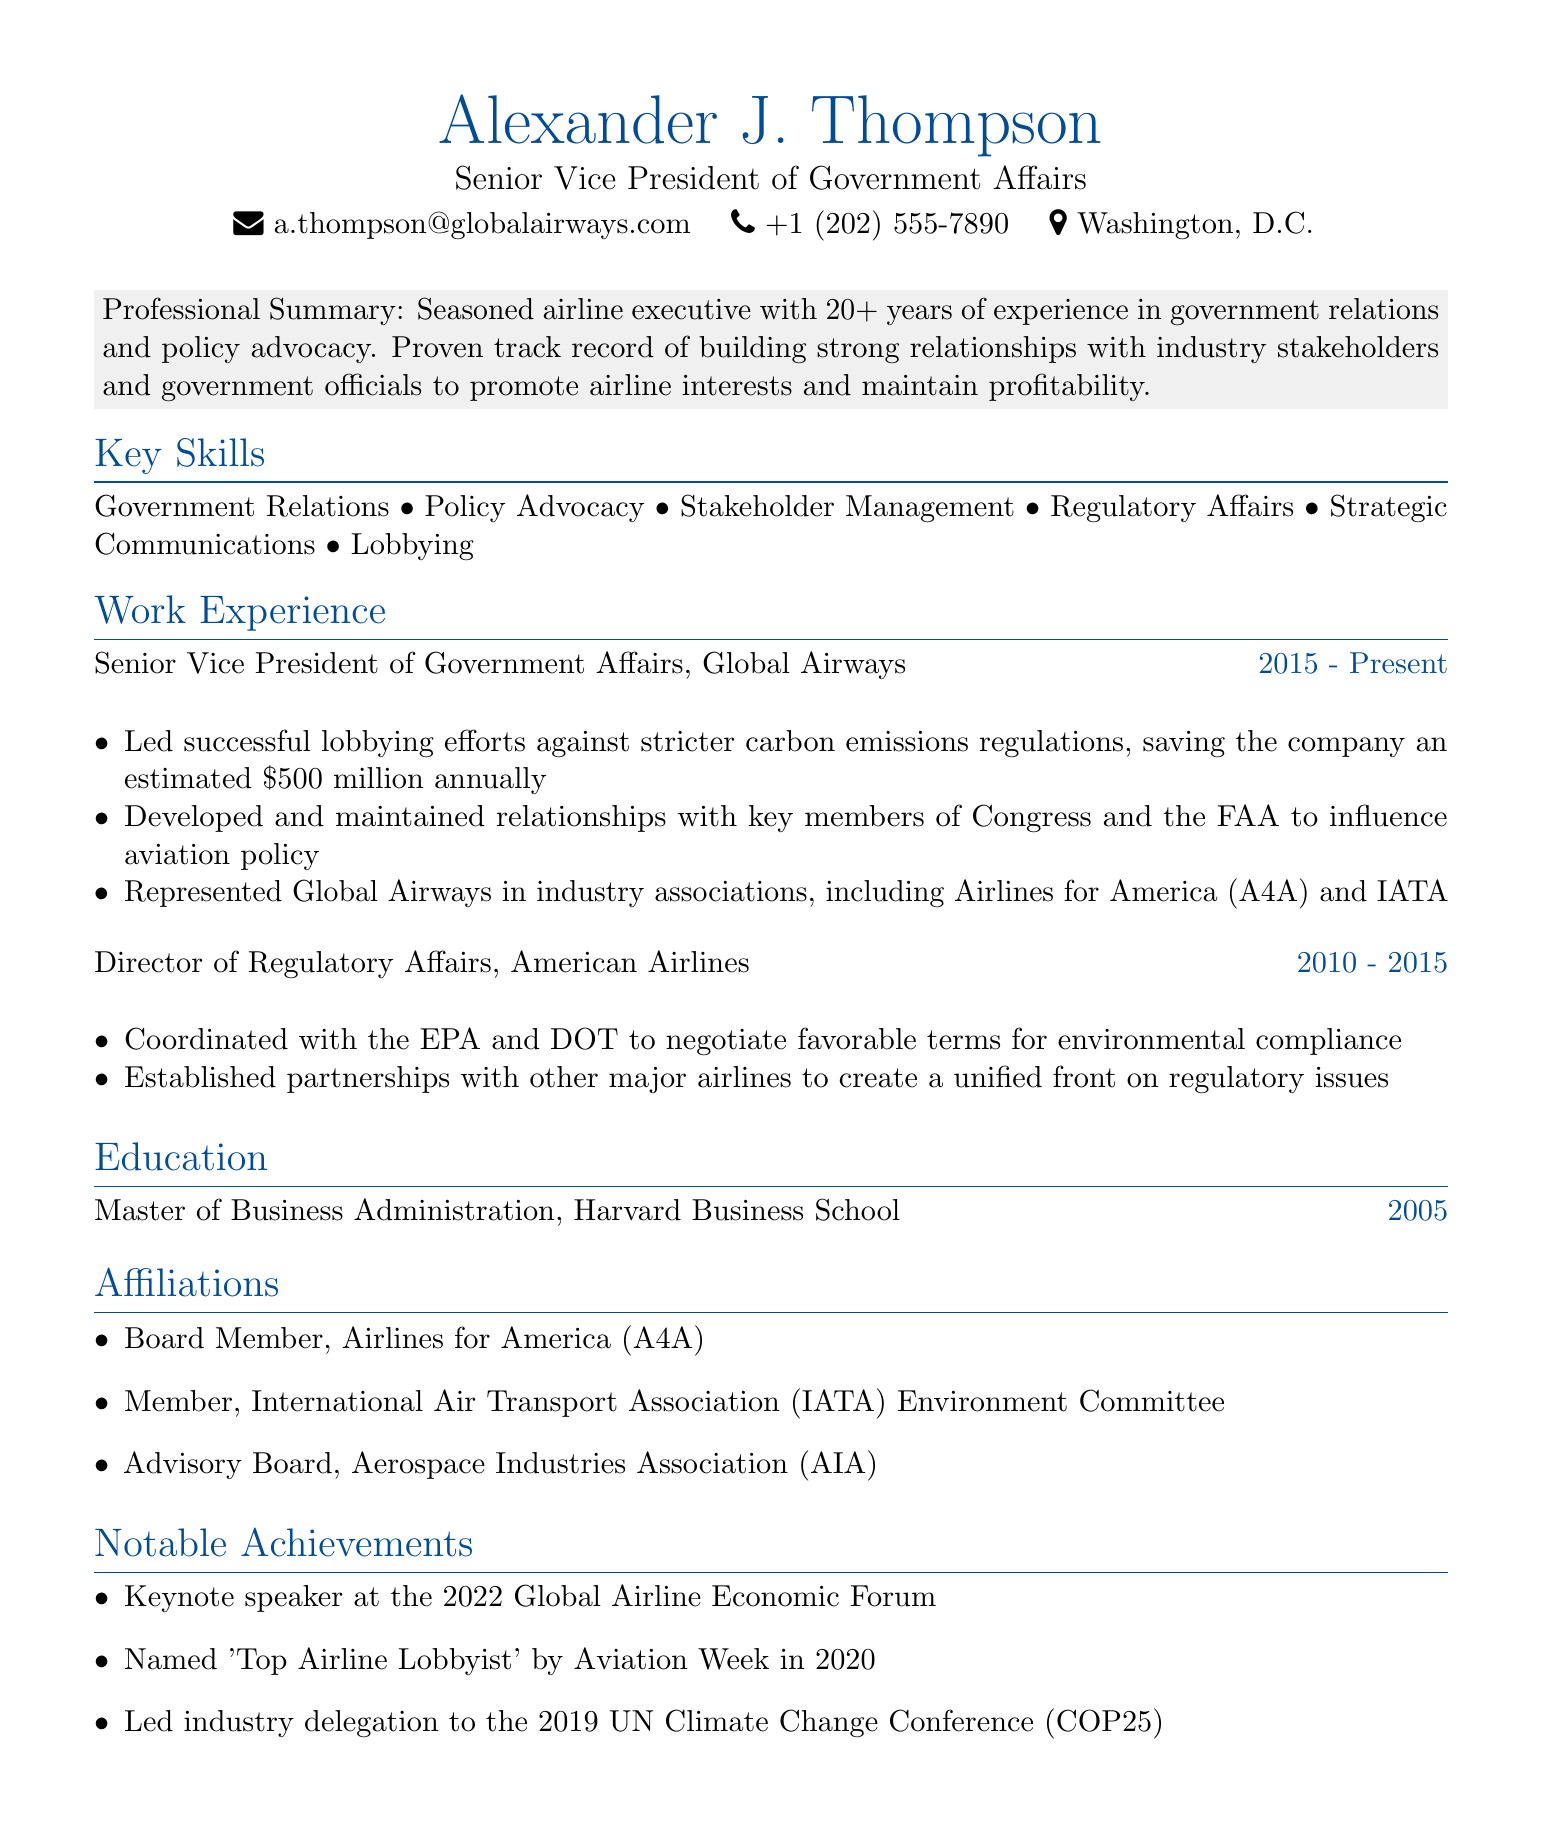What is the name of the individual? The name of the individual is clearly stated at the top of the document.
Answer: Alexander J. Thompson What is the title held by Alexander J. Thompson? The document specifies the current title held by the individual prominently.
Answer: Senior Vice President of Government Affairs How many years of experience does Alexander J. Thompson have? The professional summary mentions the total years of experience directly.
Answer: 20+ What company does Alexander J. Thompson currently work for? The work experience section identifies the company where he holds the current position.
Answer: Global Airways What estimated annual savings did lobbying efforts achieve? The achievements under the work experience section highlight the financial impact of his lobbying.
Answer: $500 million In which year did Alexander J. Thompson earn his MBA? The education section explicitly states the year of his degree.
Answer: 2005 Which industry associations does Alexander J. Thompson represent? The achievements section lists the specific industry associations he represents.
Answer: Airlines for America (A4A) and IATA What notable award was Alexander J. Thompson given in 2020? The notable achievements section outlines the recognition he received.
Answer: Top Airline Lobbyist How many years did Alexander J. Thompson serve as Director of Regulatory Affairs at American Airlines? The work experience section provides the duration for this role.
Answer: 5 years 